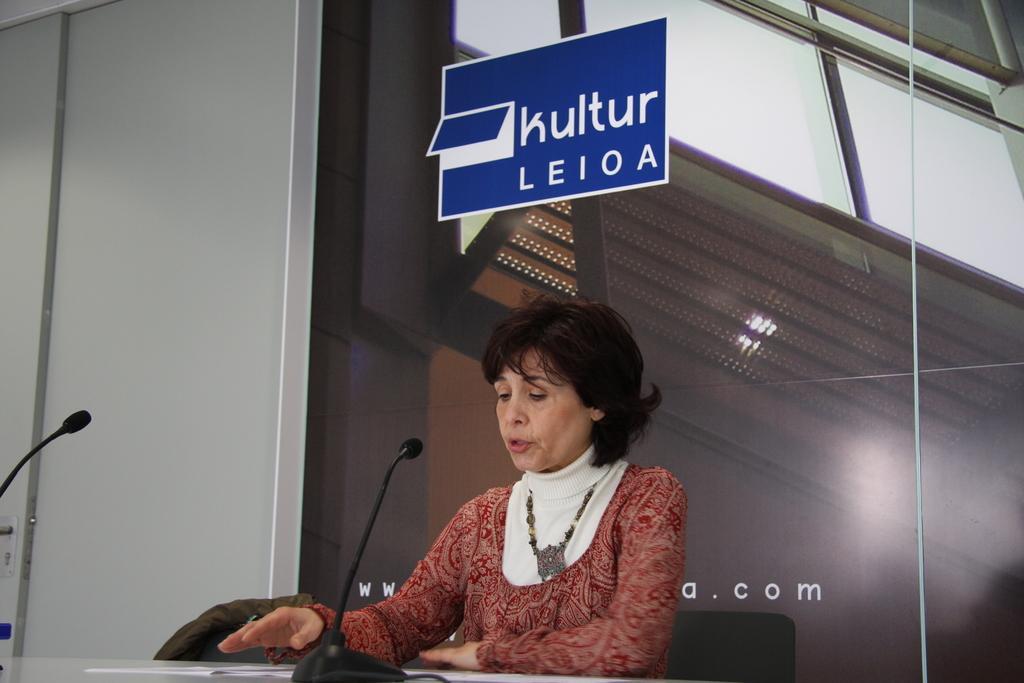In one or two sentences, can you explain what this image depicts? In the picture we can see a woman standing near the desk and talking into the microphone and in the background, we can see a wall with a glass which is black in color and some board which is blue in color and written on it as CULTURE Leioa. 